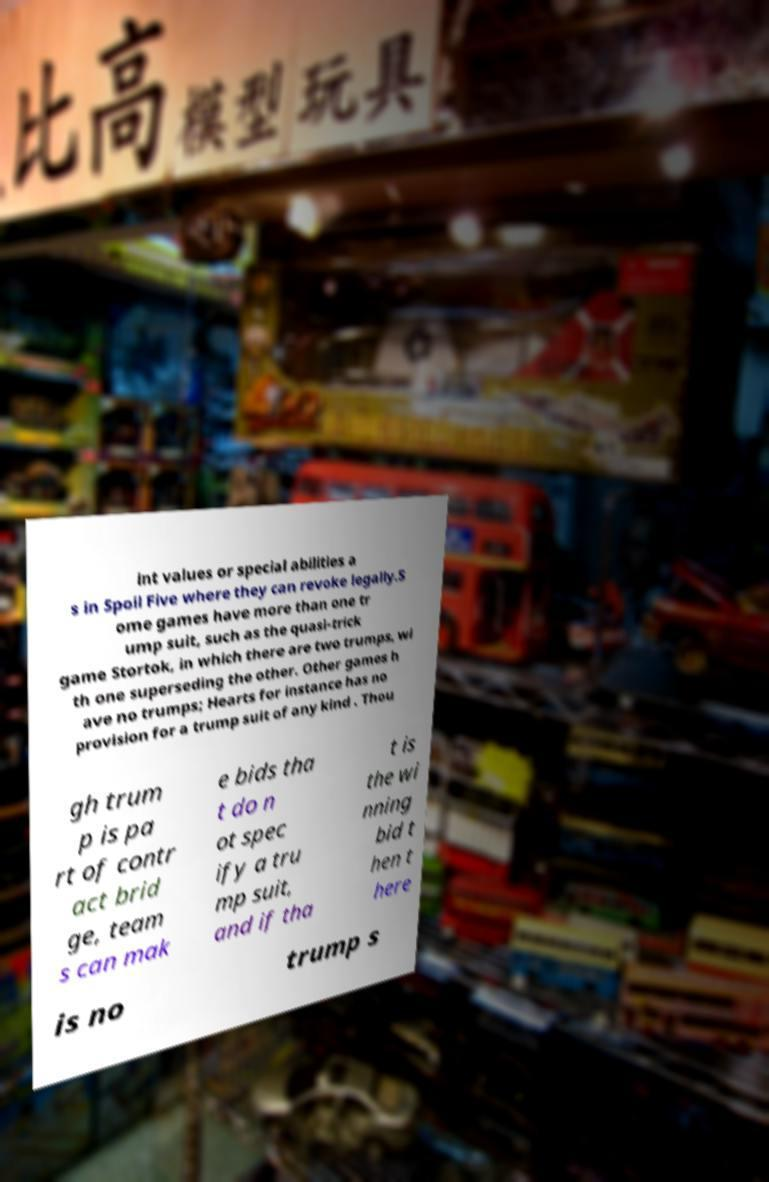I need the written content from this picture converted into text. Can you do that? int values or special abilities a s in Spoil Five where they can revoke legally.S ome games have more than one tr ump suit, such as the quasi-trick game Stortok, in which there are two trumps, wi th one superseding the other. Other games h ave no trumps; Hearts for instance has no provision for a trump suit of any kind . Thou gh trum p is pa rt of contr act brid ge, team s can mak e bids tha t do n ot spec ify a tru mp suit, and if tha t is the wi nning bid t hen t here is no trump s 